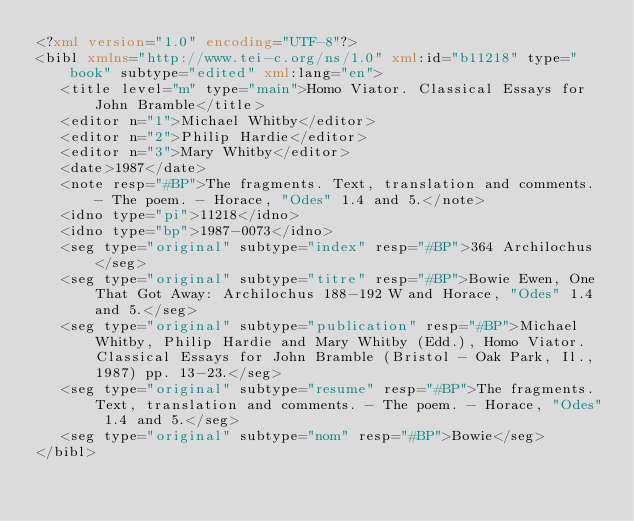<code> <loc_0><loc_0><loc_500><loc_500><_XML_><?xml version="1.0" encoding="UTF-8"?>
<bibl xmlns="http://www.tei-c.org/ns/1.0" xml:id="b11218" type="book" subtype="edited" xml:lang="en">
   <title level="m" type="main">Homo Viator. Classical Essays for John Bramble</title>
   <editor n="1">Michael Whitby</editor>
   <editor n="2">Philip Hardie</editor>
   <editor n="3">Mary Whitby</editor>
   <date>1987</date>
   <note resp="#BP">The fragments. Text, translation and comments. - The poem. - Horace, "Odes" 1.4 and 5.</note>
   <idno type="pi">11218</idno>
   <idno type="bp">1987-0073</idno>
   <seg type="original" subtype="index" resp="#BP">364 Archilochus</seg>
   <seg type="original" subtype="titre" resp="#BP">Bowie Ewen, One That Got Away: Archilochus 188-192 W and Horace, "Odes" 1.4 and 5.</seg>
   <seg type="original" subtype="publication" resp="#BP">Michael Whitby, Philip Hardie and Mary Whitby (Edd.), Homo Viator. Classical Essays for John Bramble (Bristol - Oak Park, Il., 1987) pp. 13-23.</seg>
   <seg type="original" subtype="resume" resp="#BP">The fragments. Text, translation and comments. - The poem. - Horace, "Odes" 1.4 and 5.</seg>
   <seg type="original" subtype="nom" resp="#BP">Bowie</seg>
</bibl></code> 